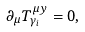Convert formula to latex. <formula><loc_0><loc_0><loc_500><loc_500>\partial _ { \mu } T ^ { \mu y } _ { \gamma _ { i } } = 0 ,</formula> 